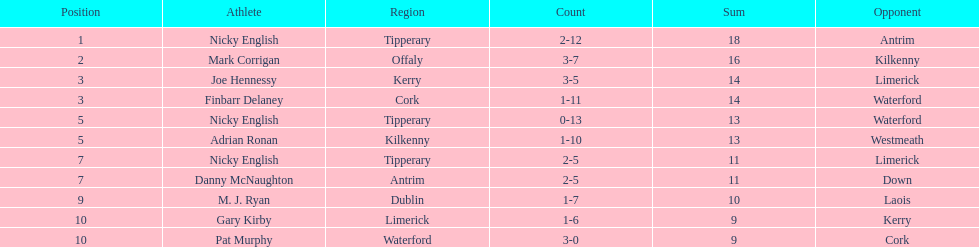How many times was waterford the opposition? 2. 